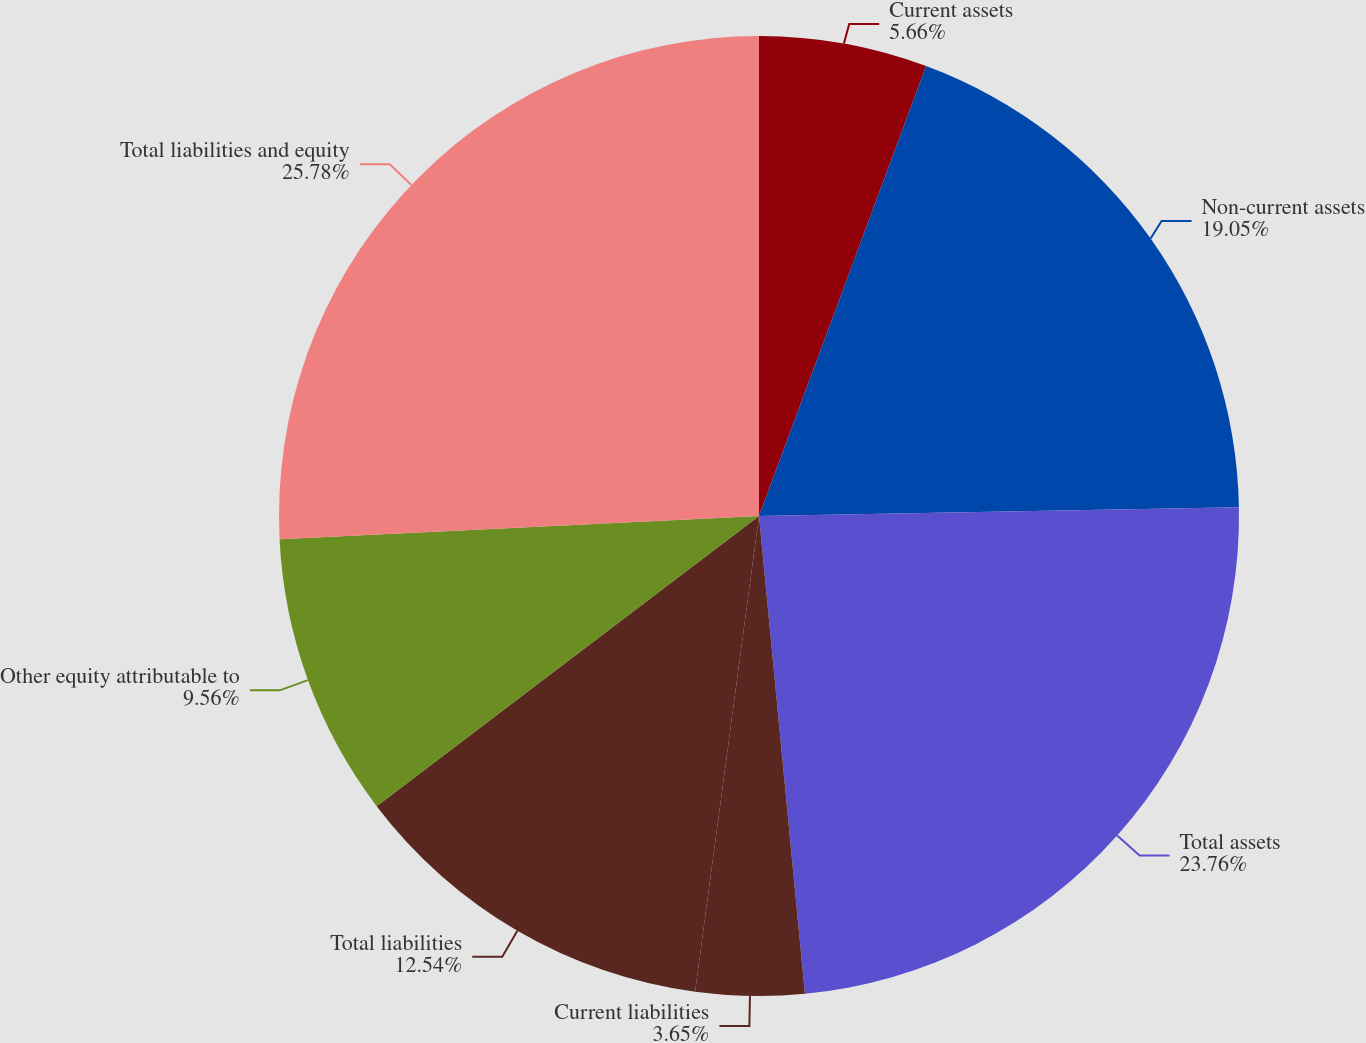Convert chart. <chart><loc_0><loc_0><loc_500><loc_500><pie_chart><fcel>Current assets<fcel>Non-current assets<fcel>Total assets<fcel>Current liabilities<fcel>Total liabilities<fcel>Other equity attributable to<fcel>Total liabilities and equity<nl><fcel>5.66%<fcel>19.05%<fcel>23.76%<fcel>3.65%<fcel>12.54%<fcel>9.56%<fcel>25.77%<nl></chart> 